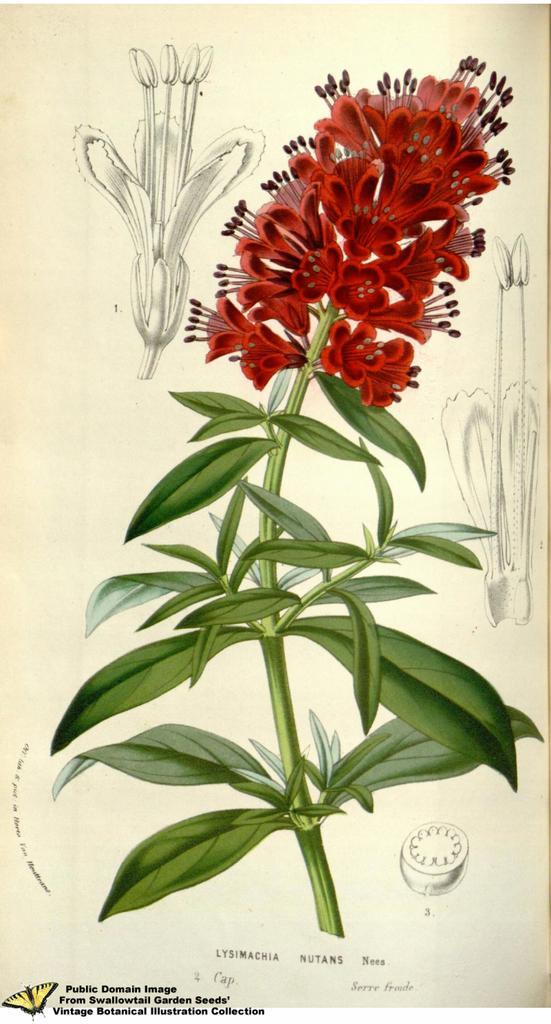Please provide a concise description of this image. Here in this picture we can see a painting of a flower present on a sheet. 